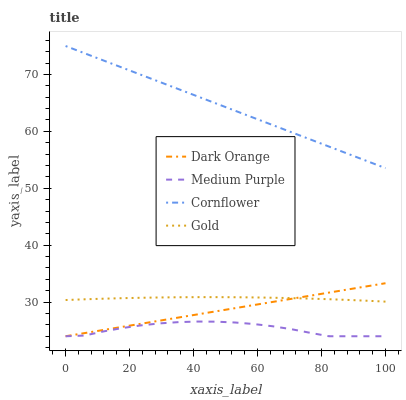Does Medium Purple have the minimum area under the curve?
Answer yes or no. Yes. Does Cornflower have the maximum area under the curve?
Answer yes or no. Yes. Does Dark Orange have the minimum area under the curve?
Answer yes or no. No. Does Dark Orange have the maximum area under the curve?
Answer yes or no. No. Is Dark Orange the smoothest?
Answer yes or no. Yes. Is Medium Purple the roughest?
Answer yes or no. Yes. Is Gold the smoothest?
Answer yes or no. No. Is Gold the roughest?
Answer yes or no. No. Does Gold have the lowest value?
Answer yes or no. No. Does Cornflower have the highest value?
Answer yes or no. Yes. Does Dark Orange have the highest value?
Answer yes or no. No. Is Dark Orange less than Cornflower?
Answer yes or no. Yes. Is Cornflower greater than Dark Orange?
Answer yes or no. Yes. Does Dark Orange intersect Gold?
Answer yes or no. Yes. Is Dark Orange less than Gold?
Answer yes or no. No. Is Dark Orange greater than Gold?
Answer yes or no. No. Does Dark Orange intersect Cornflower?
Answer yes or no. No. 